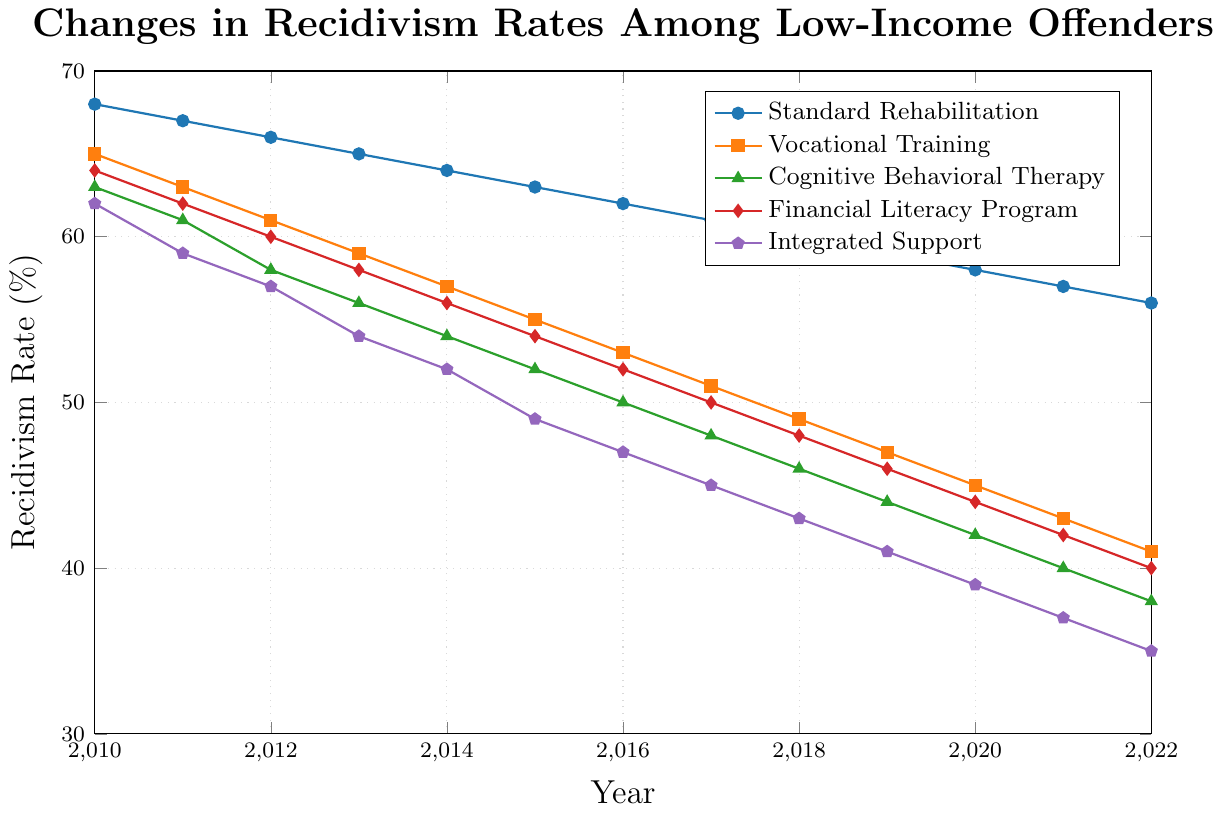Which rehabilitation program showed the greatest decrease in recidivism rates over the period 2010 to 2022? To determine which rehabilitation program showed the greatest decrease, we need to find the difference in recidivism rates between 2010 and 2022 for each program. For Standard Rehabilitation, the decrease is \(68\% - 56\% = 12\%\). For Vocational Training, it is \(65\% - 41\% = 24\%\). For Cognitive Behavioral Therapy, it is \(63\% - 38\% = 25\%\). For Financial Literacy Program, it is \(64\% - 40\% = 24\%\). For Integrated Support, it is \(62\% - 35\% = 27\%\). The largest decrease is 27\%, from Integrated Support.
Answer: Integrated Support By what percentage did the recidivism rate for Vocational Training change between 2015 and 2020? To find the percentage change, we subtract the recidivism rate for 2020 from the rate for 2015 and then divide by the 2015 rate, multiplying by 100 to convert to a percentage. \(((55\% - 45\%) / 55\%) \times 100 = (10/55) \times 100 \approx 18.18\%\).
Answer: 18.18% How does the recidivism rate in 2022 for Cognitive Behavioral Therapy compare to that for Financial Literacy Program? We look at the recidivism rate in 2022 for Cognitive Behavioral Therapy, which is 38%, and for Financial Literacy Program, which is 40%. Comparing these two, Cognitive Behavioral Therapy has a slightly lower rate.
Answer: Cognitive Behavioral Therapy is lower Among the five programs, which one had the consistently lowest recidivism rates throughout the period? To determine which program had the lowest rates throughout, we compare the rates year by year. Integrated Support consistently has the lowest recidivism rates from 2010 to 2022.
Answer: Integrated Support In which year did the recidivism rate for the Standard Rehabilitation program first fall below 65%? We look at the values for Standard Rehabilitation and find that in 2013 the rate is 65% and in 2014 it is 64%. Therefore, the rate first falls below 65% in 2014.
Answer: 2014 If you average the recidivism rates for all programs in the year 2017, what is the result? To calculate the average recidivism rate for 2017, add the rates for all programs and divide by the number of programs. \((61\% + 51\% + 48\% + 50\% + 45\%) / 5 = 51\%\).
Answer: 51% Which program showed the smallest decrease in recidivism rates from 2010 to 2022? We find the decrease from 2010 to 2022 for each program: Standard Rehabilitation (12%), Vocational Training (24%), Cognitive Behavioral Therapy (25%), Financial Literacy Program (24%), and Integrated Support (27%). The smallest decrease is 12% for Standard Rehabilitation.
Answer: Standard Rehabilitation In 2018, how much lower was the recidivism rate for Cognitive Behavioral Therapy compared to Standard Rehabilitation? The recidivism rate for Cognitive Behavioral Therapy in 2018 was 46%, and for Standard Rehabilitation, it was 60%. The difference is \(60\% - 46\% = 14\%\).
Answer: 14% What is the overall trend in recidivism rates for the Financial Literacy Program from 2010 to 2022? Observing the data, we see a continuous decline in recidivism rates for the Financial Literacy Program from 64% in 2010 to 40% in 2022, indicating a downward trend.
Answer: Downward trend How do the recidivism rates for Integrated Support and Vocational Training compare in the year 2016? For 2016, the recidivism rate is 47% for Integrated Support and 53% for Vocational Training. Integrated Support has a lower rate than Vocational Training.
Answer: Integrated Support is lower 